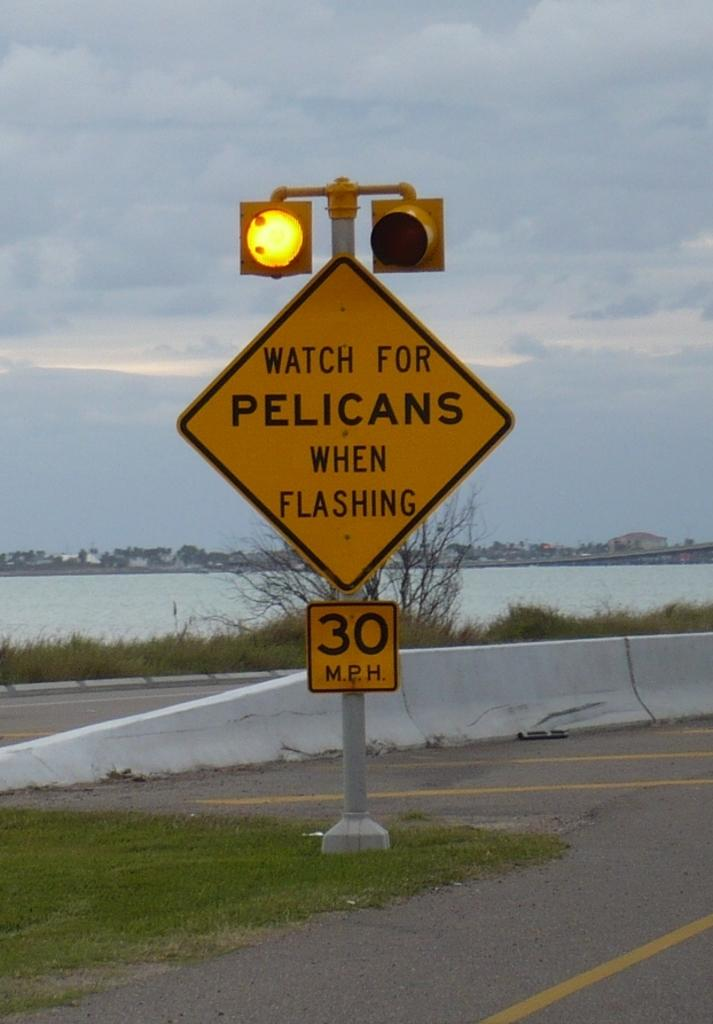<image>
Give a short and clear explanation of the subsequent image. A road sign with yellow caution lights that says to watch for pelicans. 